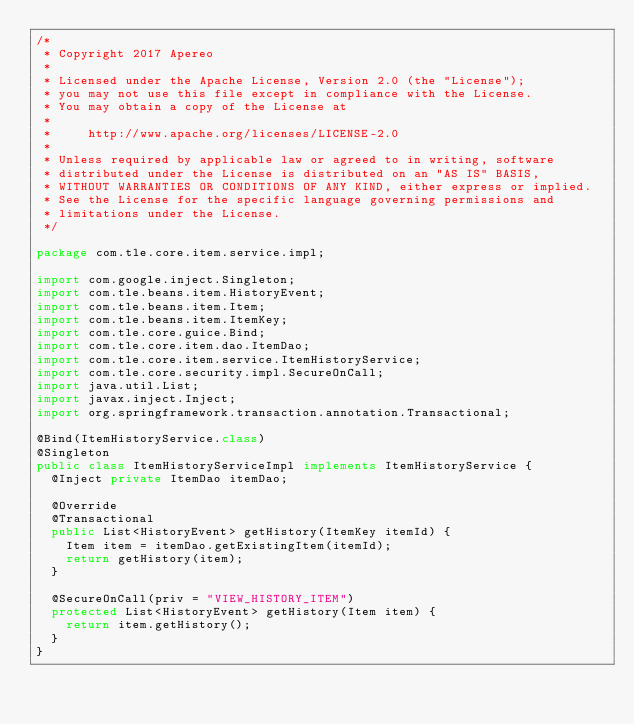Convert code to text. <code><loc_0><loc_0><loc_500><loc_500><_Java_>/*
 * Copyright 2017 Apereo
 *
 * Licensed under the Apache License, Version 2.0 (the "License");
 * you may not use this file except in compliance with the License.
 * You may obtain a copy of the License at
 *
 *     http://www.apache.org/licenses/LICENSE-2.0
 *
 * Unless required by applicable law or agreed to in writing, software
 * distributed under the License is distributed on an "AS IS" BASIS,
 * WITHOUT WARRANTIES OR CONDITIONS OF ANY KIND, either express or implied.
 * See the License for the specific language governing permissions and
 * limitations under the License.
 */

package com.tle.core.item.service.impl;

import com.google.inject.Singleton;
import com.tle.beans.item.HistoryEvent;
import com.tle.beans.item.Item;
import com.tle.beans.item.ItemKey;
import com.tle.core.guice.Bind;
import com.tle.core.item.dao.ItemDao;
import com.tle.core.item.service.ItemHistoryService;
import com.tle.core.security.impl.SecureOnCall;
import java.util.List;
import javax.inject.Inject;
import org.springframework.transaction.annotation.Transactional;

@Bind(ItemHistoryService.class)
@Singleton
public class ItemHistoryServiceImpl implements ItemHistoryService {
  @Inject private ItemDao itemDao;

  @Override
  @Transactional
  public List<HistoryEvent> getHistory(ItemKey itemId) {
    Item item = itemDao.getExistingItem(itemId);
    return getHistory(item);
  }

  @SecureOnCall(priv = "VIEW_HISTORY_ITEM")
  protected List<HistoryEvent> getHistory(Item item) {
    return item.getHistory();
  }
}
</code> 